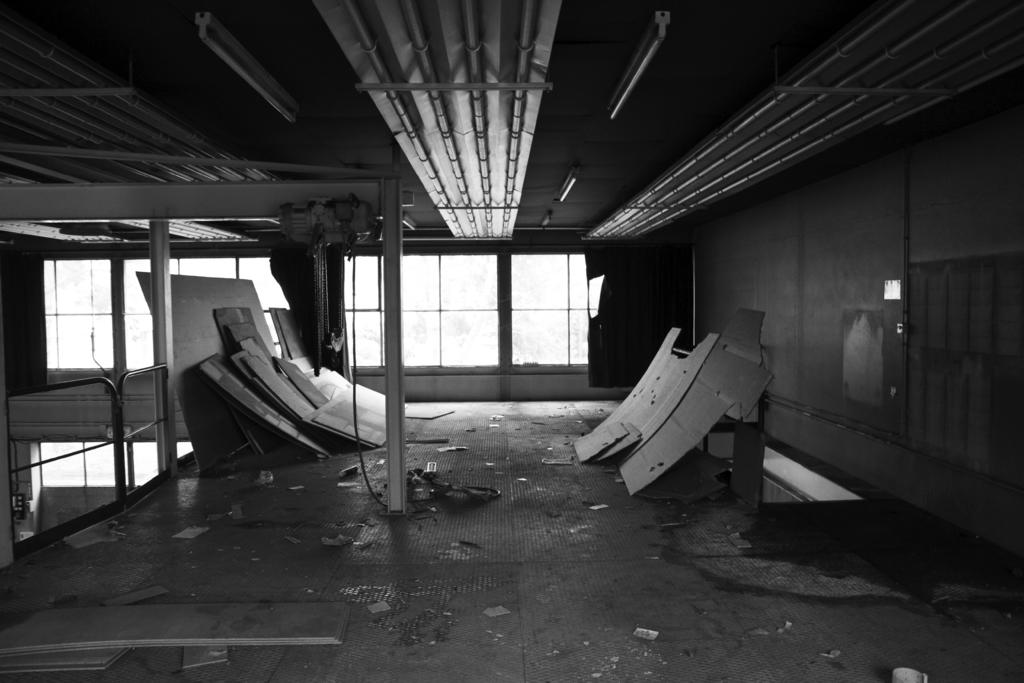What type of objects can be seen in the image? There are lights, sheets, poles, windows, and a wall visible in the image. Can you describe the color scheme of the image? The image is in black and white mode. What might the lights be used for in the image? The lights could be used for illumination or decoration in the space. What is the purpose of the poles in the image? The poles could be used to support the sheets or other objects in the space. What type of map can be seen on the wall in the image? There is no map present on the wall in the image; it only shows lights, sheets, poles, windows, and a wall. What type of seed is growing on the sheets in the image? There are no seeds or plants visible on the sheets in the image. 